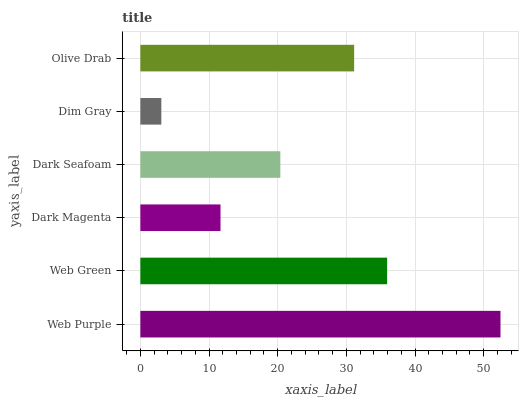Is Dim Gray the minimum?
Answer yes or no. Yes. Is Web Purple the maximum?
Answer yes or no. Yes. Is Web Green the minimum?
Answer yes or no. No. Is Web Green the maximum?
Answer yes or no. No. Is Web Purple greater than Web Green?
Answer yes or no. Yes. Is Web Green less than Web Purple?
Answer yes or no. Yes. Is Web Green greater than Web Purple?
Answer yes or no. No. Is Web Purple less than Web Green?
Answer yes or no. No. Is Olive Drab the high median?
Answer yes or no. Yes. Is Dark Seafoam the low median?
Answer yes or no. Yes. Is Dark Magenta the high median?
Answer yes or no. No. Is Web Purple the low median?
Answer yes or no. No. 